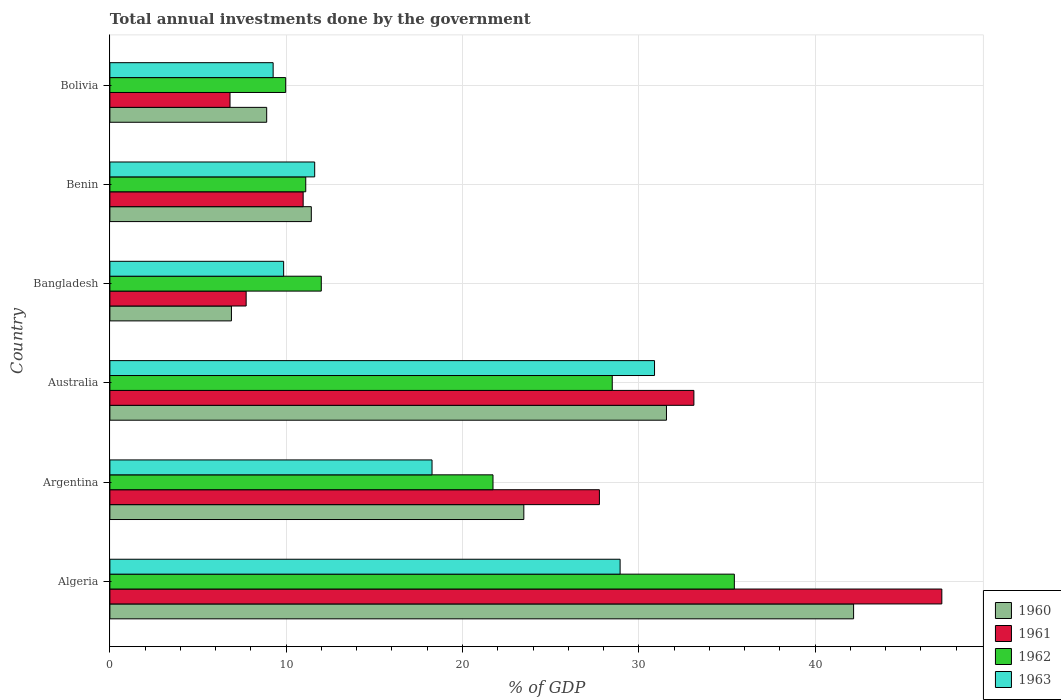How many different coloured bars are there?
Provide a succinct answer. 4. How many bars are there on the 3rd tick from the top?
Offer a terse response. 4. How many bars are there on the 1st tick from the bottom?
Provide a short and direct response. 4. What is the label of the 2nd group of bars from the top?
Keep it short and to the point. Benin. In how many cases, is the number of bars for a given country not equal to the number of legend labels?
Keep it short and to the point. 0. What is the total annual investments done by the government in 1962 in Bangladesh?
Make the answer very short. 11.99. Across all countries, what is the maximum total annual investments done by the government in 1960?
Offer a very short reply. 42.18. Across all countries, what is the minimum total annual investments done by the government in 1960?
Offer a terse response. 6.89. In which country was the total annual investments done by the government in 1962 maximum?
Make the answer very short. Algeria. In which country was the total annual investments done by the government in 1960 minimum?
Your response must be concise. Bangladesh. What is the total total annual investments done by the government in 1962 in the graph?
Ensure brevity in your answer.  118.72. What is the difference between the total annual investments done by the government in 1962 in Argentina and that in Bangladesh?
Make the answer very short. 9.74. What is the difference between the total annual investments done by the government in 1963 in Australia and the total annual investments done by the government in 1960 in Benin?
Offer a very short reply. 19.47. What is the average total annual investments done by the government in 1962 per country?
Your answer should be very brief. 19.79. What is the difference between the total annual investments done by the government in 1961 and total annual investments done by the government in 1963 in Australia?
Provide a short and direct response. 2.23. What is the ratio of the total annual investments done by the government in 1961 in Australia to that in Benin?
Make the answer very short. 3.02. Is the total annual investments done by the government in 1961 in Algeria less than that in Bolivia?
Provide a short and direct response. No. What is the difference between the highest and the second highest total annual investments done by the government in 1962?
Give a very brief answer. 6.93. What is the difference between the highest and the lowest total annual investments done by the government in 1962?
Give a very brief answer. 25.45. Is it the case that in every country, the sum of the total annual investments done by the government in 1963 and total annual investments done by the government in 1962 is greater than the sum of total annual investments done by the government in 1961 and total annual investments done by the government in 1960?
Your answer should be compact. No. What does the 4th bar from the bottom in Bangladesh represents?
Your answer should be compact. 1963. Is it the case that in every country, the sum of the total annual investments done by the government in 1960 and total annual investments done by the government in 1963 is greater than the total annual investments done by the government in 1962?
Keep it short and to the point. Yes. How many bars are there?
Keep it short and to the point. 24. What is the difference between two consecutive major ticks on the X-axis?
Provide a succinct answer. 10. Does the graph contain any zero values?
Your answer should be compact. No. Does the graph contain grids?
Keep it short and to the point. Yes. How are the legend labels stacked?
Provide a short and direct response. Vertical. What is the title of the graph?
Your answer should be compact. Total annual investments done by the government. Does "1982" appear as one of the legend labels in the graph?
Your response must be concise. No. What is the label or title of the X-axis?
Give a very brief answer. % of GDP. What is the label or title of the Y-axis?
Your response must be concise. Country. What is the % of GDP of 1960 in Algeria?
Give a very brief answer. 42.18. What is the % of GDP of 1961 in Algeria?
Your answer should be very brief. 47.19. What is the % of GDP of 1962 in Algeria?
Give a very brief answer. 35.42. What is the % of GDP in 1963 in Algeria?
Keep it short and to the point. 28.94. What is the % of GDP in 1960 in Argentina?
Offer a very short reply. 23.48. What is the % of GDP of 1961 in Argentina?
Keep it short and to the point. 27.77. What is the % of GDP of 1962 in Argentina?
Offer a terse response. 21.73. What is the % of GDP of 1963 in Argentina?
Ensure brevity in your answer.  18.27. What is the % of GDP of 1960 in Australia?
Give a very brief answer. 31.57. What is the % of GDP in 1961 in Australia?
Your answer should be very brief. 33.13. What is the % of GDP in 1962 in Australia?
Provide a short and direct response. 28.49. What is the % of GDP of 1963 in Australia?
Ensure brevity in your answer.  30.89. What is the % of GDP of 1960 in Bangladesh?
Your response must be concise. 6.89. What is the % of GDP of 1961 in Bangladesh?
Your response must be concise. 7.73. What is the % of GDP of 1962 in Bangladesh?
Keep it short and to the point. 11.99. What is the % of GDP in 1963 in Bangladesh?
Your answer should be compact. 9.86. What is the % of GDP of 1960 in Benin?
Your answer should be compact. 11.42. What is the % of GDP in 1961 in Benin?
Make the answer very short. 10.96. What is the % of GDP in 1962 in Benin?
Provide a short and direct response. 11.11. What is the % of GDP of 1963 in Benin?
Make the answer very short. 11.62. What is the % of GDP in 1960 in Bolivia?
Keep it short and to the point. 8.89. What is the % of GDP in 1961 in Bolivia?
Offer a very short reply. 6.81. What is the % of GDP in 1962 in Bolivia?
Your answer should be compact. 9.97. What is the % of GDP of 1963 in Bolivia?
Your answer should be compact. 9.26. Across all countries, what is the maximum % of GDP in 1960?
Keep it short and to the point. 42.18. Across all countries, what is the maximum % of GDP of 1961?
Give a very brief answer. 47.19. Across all countries, what is the maximum % of GDP of 1962?
Ensure brevity in your answer.  35.42. Across all countries, what is the maximum % of GDP of 1963?
Your response must be concise. 30.89. Across all countries, what is the minimum % of GDP in 1960?
Make the answer very short. 6.89. Across all countries, what is the minimum % of GDP of 1961?
Your answer should be very brief. 6.81. Across all countries, what is the minimum % of GDP in 1962?
Make the answer very short. 9.97. Across all countries, what is the minimum % of GDP of 1963?
Offer a terse response. 9.26. What is the total % of GDP in 1960 in the graph?
Your answer should be very brief. 124.45. What is the total % of GDP of 1961 in the graph?
Offer a terse response. 133.59. What is the total % of GDP of 1962 in the graph?
Keep it short and to the point. 118.72. What is the total % of GDP of 1963 in the graph?
Keep it short and to the point. 108.84. What is the difference between the % of GDP in 1960 in Algeria and that in Argentina?
Make the answer very short. 18.71. What is the difference between the % of GDP of 1961 in Algeria and that in Argentina?
Make the answer very short. 19.42. What is the difference between the % of GDP in 1962 in Algeria and that in Argentina?
Provide a short and direct response. 13.69. What is the difference between the % of GDP in 1963 in Algeria and that in Argentina?
Your answer should be very brief. 10.67. What is the difference between the % of GDP of 1960 in Algeria and that in Australia?
Offer a terse response. 10.61. What is the difference between the % of GDP in 1961 in Algeria and that in Australia?
Your response must be concise. 14.06. What is the difference between the % of GDP in 1962 in Algeria and that in Australia?
Your response must be concise. 6.93. What is the difference between the % of GDP of 1963 in Algeria and that in Australia?
Your answer should be very brief. -1.95. What is the difference between the % of GDP in 1960 in Algeria and that in Bangladesh?
Your answer should be compact. 35.29. What is the difference between the % of GDP in 1961 in Algeria and that in Bangladesh?
Your response must be concise. 39.46. What is the difference between the % of GDP in 1962 in Algeria and that in Bangladesh?
Your response must be concise. 23.43. What is the difference between the % of GDP of 1963 in Algeria and that in Bangladesh?
Your response must be concise. 19.09. What is the difference between the % of GDP in 1960 in Algeria and that in Benin?
Provide a succinct answer. 30.76. What is the difference between the % of GDP in 1961 in Algeria and that in Benin?
Provide a short and direct response. 36.23. What is the difference between the % of GDP of 1962 in Algeria and that in Benin?
Ensure brevity in your answer.  24.31. What is the difference between the % of GDP in 1963 in Algeria and that in Benin?
Your answer should be compact. 17.32. What is the difference between the % of GDP of 1960 in Algeria and that in Bolivia?
Your response must be concise. 33.29. What is the difference between the % of GDP of 1961 in Algeria and that in Bolivia?
Make the answer very short. 40.38. What is the difference between the % of GDP of 1962 in Algeria and that in Bolivia?
Your answer should be very brief. 25.45. What is the difference between the % of GDP in 1963 in Algeria and that in Bolivia?
Ensure brevity in your answer.  19.68. What is the difference between the % of GDP of 1960 in Argentina and that in Australia?
Your response must be concise. -8.09. What is the difference between the % of GDP in 1961 in Argentina and that in Australia?
Keep it short and to the point. -5.36. What is the difference between the % of GDP in 1962 in Argentina and that in Australia?
Your response must be concise. -6.76. What is the difference between the % of GDP of 1963 in Argentina and that in Australia?
Provide a succinct answer. -12.62. What is the difference between the % of GDP of 1960 in Argentina and that in Bangladesh?
Ensure brevity in your answer.  16.59. What is the difference between the % of GDP of 1961 in Argentina and that in Bangladesh?
Provide a short and direct response. 20.04. What is the difference between the % of GDP in 1962 in Argentina and that in Bangladesh?
Offer a terse response. 9.74. What is the difference between the % of GDP of 1963 in Argentina and that in Bangladesh?
Offer a terse response. 8.42. What is the difference between the % of GDP in 1960 in Argentina and that in Benin?
Your answer should be very brief. 12.05. What is the difference between the % of GDP in 1961 in Argentina and that in Benin?
Make the answer very short. 16.8. What is the difference between the % of GDP of 1962 in Argentina and that in Benin?
Give a very brief answer. 10.62. What is the difference between the % of GDP of 1963 in Argentina and that in Benin?
Your answer should be compact. 6.66. What is the difference between the % of GDP of 1960 in Argentina and that in Bolivia?
Provide a succinct answer. 14.59. What is the difference between the % of GDP of 1961 in Argentina and that in Bolivia?
Offer a terse response. 20.95. What is the difference between the % of GDP of 1962 in Argentina and that in Bolivia?
Ensure brevity in your answer.  11.76. What is the difference between the % of GDP of 1963 in Argentina and that in Bolivia?
Offer a very short reply. 9.01. What is the difference between the % of GDP in 1960 in Australia and that in Bangladesh?
Offer a very short reply. 24.68. What is the difference between the % of GDP of 1961 in Australia and that in Bangladesh?
Offer a very short reply. 25.4. What is the difference between the % of GDP in 1962 in Australia and that in Bangladesh?
Your answer should be very brief. 16.5. What is the difference between the % of GDP of 1963 in Australia and that in Bangladesh?
Your answer should be compact. 21.04. What is the difference between the % of GDP in 1960 in Australia and that in Benin?
Give a very brief answer. 20.15. What is the difference between the % of GDP of 1961 in Australia and that in Benin?
Ensure brevity in your answer.  22.16. What is the difference between the % of GDP of 1962 in Australia and that in Benin?
Ensure brevity in your answer.  17.39. What is the difference between the % of GDP of 1963 in Australia and that in Benin?
Provide a succinct answer. 19.28. What is the difference between the % of GDP of 1960 in Australia and that in Bolivia?
Give a very brief answer. 22.68. What is the difference between the % of GDP in 1961 in Australia and that in Bolivia?
Offer a very short reply. 26.31. What is the difference between the % of GDP of 1962 in Australia and that in Bolivia?
Your response must be concise. 18.52. What is the difference between the % of GDP of 1963 in Australia and that in Bolivia?
Your answer should be very brief. 21.63. What is the difference between the % of GDP in 1960 in Bangladesh and that in Benin?
Provide a succinct answer. -4.53. What is the difference between the % of GDP in 1961 in Bangladesh and that in Benin?
Offer a terse response. -3.23. What is the difference between the % of GDP in 1962 in Bangladesh and that in Benin?
Give a very brief answer. 0.88. What is the difference between the % of GDP in 1963 in Bangladesh and that in Benin?
Offer a very short reply. -1.76. What is the difference between the % of GDP in 1961 in Bangladesh and that in Bolivia?
Keep it short and to the point. 0.92. What is the difference between the % of GDP in 1962 in Bangladesh and that in Bolivia?
Offer a terse response. 2.02. What is the difference between the % of GDP in 1963 in Bangladesh and that in Bolivia?
Give a very brief answer. 0.6. What is the difference between the % of GDP of 1960 in Benin and that in Bolivia?
Provide a succinct answer. 2.53. What is the difference between the % of GDP in 1961 in Benin and that in Bolivia?
Provide a succinct answer. 4.15. What is the difference between the % of GDP of 1962 in Benin and that in Bolivia?
Offer a terse response. 1.14. What is the difference between the % of GDP of 1963 in Benin and that in Bolivia?
Make the answer very short. 2.36. What is the difference between the % of GDP in 1960 in Algeria and the % of GDP in 1961 in Argentina?
Your answer should be compact. 14.42. What is the difference between the % of GDP in 1960 in Algeria and the % of GDP in 1962 in Argentina?
Give a very brief answer. 20.45. What is the difference between the % of GDP in 1960 in Algeria and the % of GDP in 1963 in Argentina?
Keep it short and to the point. 23.91. What is the difference between the % of GDP of 1961 in Algeria and the % of GDP of 1962 in Argentina?
Make the answer very short. 25.46. What is the difference between the % of GDP in 1961 in Algeria and the % of GDP in 1963 in Argentina?
Offer a terse response. 28.92. What is the difference between the % of GDP of 1962 in Algeria and the % of GDP of 1963 in Argentina?
Offer a very short reply. 17.15. What is the difference between the % of GDP of 1960 in Algeria and the % of GDP of 1961 in Australia?
Your response must be concise. 9.06. What is the difference between the % of GDP in 1960 in Algeria and the % of GDP in 1962 in Australia?
Your answer should be very brief. 13.69. What is the difference between the % of GDP of 1960 in Algeria and the % of GDP of 1963 in Australia?
Give a very brief answer. 11.29. What is the difference between the % of GDP in 1961 in Algeria and the % of GDP in 1962 in Australia?
Your response must be concise. 18.69. What is the difference between the % of GDP in 1961 in Algeria and the % of GDP in 1963 in Australia?
Keep it short and to the point. 16.3. What is the difference between the % of GDP in 1962 in Algeria and the % of GDP in 1963 in Australia?
Give a very brief answer. 4.53. What is the difference between the % of GDP in 1960 in Algeria and the % of GDP in 1961 in Bangladesh?
Keep it short and to the point. 34.46. What is the difference between the % of GDP in 1960 in Algeria and the % of GDP in 1962 in Bangladesh?
Provide a short and direct response. 30.19. What is the difference between the % of GDP in 1960 in Algeria and the % of GDP in 1963 in Bangladesh?
Your answer should be very brief. 32.33. What is the difference between the % of GDP of 1961 in Algeria and the % of GDP of 1962 in Bangladesh?
Your answer should be compact. 35.2. What is the difference between the % of GDP in 1961 in Algeria and the % of GDP in 1963 in Bangladesh?
Ensure brevity in your answer.  37.33. What is the difference between the % of GDP in 1962 in Algeria and the % of GDP in 1963 in Bangladesh?
Make the answer very short. 25.57. What is the difference between the % of GDP in 1960 in Algeria and the % of GDP in 1961 in Benin?
Offer a terse response. 31.22. What is the difference between the % of GDP in 1960 in Algeria and the % of GDP in 1962 in Benin?
Offer a very short reply. 31.08. What is the difference between the % of GDP in 1960 in Algeria and the % of GDP in 1963 in Benin?
Provide a short and direct response. 30.57. What is the difference between the % of GDP in 1961 in Algeria and the % of GDP in 1962 in Benin?
Provide a succinct answer. 36.08. What is the difference between the % of GDP of 1961 in Algeria and the % of GDP of 1963 in Benin?
Provide a succinct answer. 35.57. What is the difference between the % of GDP in 1962 in Algeria and the % of GDP in 1963 in Benin?
Make the answer very short. 23.8. What is the difference between the % of GDP of 1960 in Algeria and the % of GDP of 1961 in Bolivia?
Your response must be concise. 35.37. What is the difference between the % of GDP of 1960 in Algeria and the % of GDP of 1962 in Bolivia?
Keep it short and to the point. 32.21. What is the difference between the % of GDP of 1960 in Algeria and the % of GDP of 1963 in Bolivia?
Your answer should be very brief. 32.92. What is the difference between the % of GDP of 1961 in Algeria and the % of GDP of 1962 in Bolivia?
Provide a succinct answer. 37.22. What is the difference between the % of GDP in 1961 in Algeria and the % of GDP in 1963 in Bolivia?
Make the answer very short. 37.93. What is the difference between the % of GDP in 1962 in Algeria and the % of GDP in 1963 in Bolivia?
Your answer should be compact. 26.16. What is the difference between the % of GDP of 1960 in Argentina and the % of GDP of 1961 in Australia?
Offer a terse response. -9.65. What is the difference between the % of GDP of 1960 in Argentina and the % of GDP of 1962 in Australia?
Your answer should be very brief. -5.02. What is the difference between the % of GDP of 1960 in Argentina and the % of GDP of 1963 in Australia?
Offer a very short reply. -7.41. What is the difference between the % of GDP in 1961 in Argentina and the % of GDP in 1962 in Australia?
Give a very brief answer. -0.73. What is the difference between the % of GDP of 1961 in Argentina and the % of GDP of 1963 in Australia?
Offer a terse response. -3.13. What is the difference between the % of GDP in 1962 in Argentina and the % of GDP in 1963 in Australia?
Make the answer very short. -9.16. What is the difference between the % of GDP of 1960 in Argentina and the % of GDP of 1961 in Bangladesh?
Give a very brief answer. 15.75. What is the difference between the % of GDP of 1960 in Argentina and the % of GDP of 1962 in Bangladesh?
Provide a succinct answer. 11.49. What is the difference between the % of GDP in 1960 in Argentina and the % of GDP in 1963 in Bangladesh?
Your answer should be compact. 13.62. What is the difference between the % of GDP in 1961 in Argentina and the % of GDP in 1962 in Bangladesh?
Provide a succinct answer. 15.78. What is the difference between the % of GDP in 1961 in Argentina and the % of GDP in 1963 in Bangladesh?
Your answer should be very brief. 17.91. What is the difference between the % of GDP in 1962 in Argentina and the % of GDP in 1963 in Bangladesh?
Give a very brief answer. 11.88. What is the difference between the % of GDP in 1960 in Argentina and the % of GDP in 1961 in Benin?
Make the answer very short. 12.52. What is the difference between the % of GDP of 1960 in Argentina and the % of GDP of 1962 in Benin?
Make the answer very short. 12.37. What is the difference between the % of GDP of 1960 in Argentina and the % of GDP of 1963 in Benin?
Make the answer very short. 11.86. What is the difference between the % of GDP of 1961 in Argentina and the % of GDP of 1962 in Benin?
Make the answer very short. 16.66. What is the difference between the % of GDP in 1961 in Argentina and the % of GDP in 1963 in Benin?
Offer a very short reply. 16.15. What is the difference between the % of GDP of 1962 in Argentina and the % of GDP of 1963 in Benin?
Your answer should be very brief. 10.11. What is the difference between the % of GDP in 1960 in Argentina and the % of GDP in 1961 in Bolivia?
Give a very brief answer. 16.67. What is the difference between the % of GDP of 1960 in Argentina and the % of GDP of 1962 in Bolivia?
Your response must be concise. 13.51. What is the difference between the % of GDP of 1960 in Argentina and the % of GDP of 1963 in Bolivia?
Offer a terse response. 14.22. What is the difference between the % of GDP in 1961 in Argentina and the % of GDP in 1962 in Bolivia?
Your response must be concise. 17.8. What is the difference between the % of GDP of 1961 in Argentina and the % of GDP of 1963 in Bolivia?
Ensure brevity in your answer.  18.51. What is the difference between the % of GDP in 1962 in Argentina and the % of GDP in 1963 in Bolivia?
Your response must be concise. 12.47. What is the difference between the % of GDP of 1960 in Australia and the % of GDP of 1961 in Bangladesh?
Your answer should be very brief. 23.84. What is the difference between the % of GDP in 1960 in Australia and the % of GDP in 1962 in Bangladesh?
Offer a terse response. 19.58. What is the difference between the % of GDP of 1960 in Australia and the % of GDP of 1963 in Bangladesh?
Make the answer very short. 21.71. What is the difference between the % of GDP of 1961 in Australia and the % of GDP of 1962 in Bangladesh?
Make the answer very short. 21.14. What is the difference between the % of GDP in 1961 in Australia and the % of GDP in 1963 in Bangladesh?
Give a very brief answer. 23.27. What is the difference between the % of GDP in 1962 in Australia and the % of GDP in 1963 in Bangladesh?
Provide a succinct answer. 18.64. What is the difference between the % of GDP of 1960 in Australia and the % of GDP of 1961 in Benin?
Make the answer very short. 20.61. What is the difference between the % of GDP of 1960 in Australia and the % of GDP of 1962 in Benin?
Provide a short and direct response. 20.46. What is the difference between the % of GDP of 1960 in Australia and the % of GDP of 1963 in Benin?
Offer a very short reply. 19.95. What is the difference between the % of GDP in 1961 in Australia and the % of GDP in 1962 in Benin?
Your answer should be very brief. 22.02. What is the difference between the % of GDP in 1961 in Australia and the % of GDP in 1963 in Benin?
Give a very brief answer. 21.51. What is the difference between the % of GDP of 1962 in Australia and the % of GDP of 1963 in Benin?
Ensure brevity in your answer.  16.88. What is the difference between the % of GDP of 1960 in Australia and the % of GDP of 1961 in Bolivia?
Keep it short and to the point. 24.76. What is the difference between the % of GDP of 1960 in Australia and the % of GDP of 1962 in Bolivia?
Offer a very short reply. 21.6. What is the difference between the % of GDP in 1960 in Australia and the % of GDP in 1963 in Bolivia?
Give a very brief answer. 22.31. What is the difference between the % of GDP of 1961 in Australia and the % of GDP of 1962 in Bolivia?
Your answer should be very brief. 23.16. What is the difference between the % of GDP in 1961 in Australia and the % of GDP in 1963 in Bolivia?
Offer a terse response. 23.87. What is the difference between the % of GDP in 1962 in Australia and the % of GDP in 1963 in Bolivia?
Provide a succinct answer. 19.23. What is the difference between the % of GDP in 1960 in Bangladesh and the % of GDP in 1961 in Benin?
Offer a very short reply. -4.07. What is the difference between the % of GDP in 1960 in Bangladesh and the % of GDP in 1962 in Benin?
Your response must be concise. -4.21. What is the difference between the % of GDP of 1960 in Bangladesh and the % of GDP of 1963 in Benin?
Provide a succinct answer. -4.72. What is the difference between the % of GDP in 1961 in Bangladesh and the % of GDP in 1962 in Benin?
Offer a terse response. -3.38. What is the difference between the % of GDP of 1961 in Bangladesh and the % of GDP of 1963 in Benin?
Your answer should be compact. -3.89. What is the difference between the % of GDP in 1962 in Bangladesh and the % of GDP in 1963 in Benin?
Your answer should be compact. 0.37. What is the difference between the % of GDP of 1960 in Bangladesh and the % of GDP of 1961 in Bolivia?
Keep it short and to the point. 0.08. What is the difference between the % of GDP in 1960 in Bangladesh and the % of GDP in 1962 in Bolivia?
Your answer should be very brief. -3.08. What is the difference between the % of GDP in 1960 in Bangladesh and the % of GDP in 1963 in Bolivia?
Make the answer very short. -2.37. What is the difference between the % of GDP in 1961 in Bangladesh and the % of GDP in 1962 in Bolivia?
Ensure brevity in your answer.  -2.24. What is the difference between the % of GDP of 1961 in Bangladesh and the % of GDP of 1963 in Bolivia?
Your response must be concise. -1.53. What is the difference between the % of GDP of 1962 in Bangladesh and the % of GDP of 1963 in Bolivia?
Provide a short and direct response. 2.73. What is the difference between the % of GDP of 1960 in Benin and the % of GDP of 1961 in Bolivia?
Offer a terse response. 4.61. What is the difference between the % of GDP in 1960 in Benin and the % of GDP in 1962 in Bolivia?
Make the answer very short. 1.45. What is the difference between the % of GDP in 1960 in Benin and the % of GDP in 1963 in Bolivia?
Ensure brevity in your answer.  2.16. What is the difference between the % of GDP of 1961 in Benin and the % of GDP of 1962 in Bolivia?
Your response must be concise. 0.99. What is the difference between the % of GDP of 1961 in Benin and the % of GDP of 1963 in Bolivia?
Give a very brief answer. 1.7. What is the difference between the % of GDP in 1962 in Benin and the % of GDP in 1963 in Bolivia?
Offer a very short reply. 1.85. What is the average % of GDP of 1960 per country?
Your answer should be very brief. 20.74. What is the average % of GDP of 1961 per country?
Your response must be concise. 22.26. What is the average % of GDP in 1962 per country?
Provide a short and direct response. 19.79. What is the average % of GDP of 1963 per country?
Offer a very short reply. 18.14. What is the difference between the % of GDP in 1960 and % of GDP in 1961 in Algeria?
Provide a short and direct response. -5. What is the difference between the % of GDP in 1960 and % of GDP in 1962 in Algeria?
Ensure brevity in your answer.  6.76. What is the difference between the % of GDP of 1960 and % of GDP of 1963 in Algeria?
Your response must be concise. 13.24. What is the difference between the % of GDP in 1961 and % of GDP in 1962 in Algeria?
Your answer should be very brief. 11.77. What is the difference between the % of GDP in 1961 and % of GDP in 1963 in Algeria?
Your answer should be very brief. 18.25. What is the difference between the % of GDP of 1962 and % of GDP of 1963 in Algeria?
Provide a succinct answer. 6.48. What is the difference between the % of GDP in 1960 and % of GDP in 1961 in Argentina?
Make the answer very short. -4.29. What is the difference between the % of GDP in 1960 and % of GDP in 1962 in Argentina?
Make the answer very short. 1.75. What is the difference between the % of GDP of 1960 and % of GDP of 1963 in Argentina?
Your answer should be very brief. 5.21. What is the difference between the % of GDP of 1961 and % of GDP of 1962 in Argentina?
Offer a terse response. 6.04. What is the difference between the % of GDP of 1961 and % of GDP of 1963 in Argentina?
Your answer should be compact. 9.49. What is the difference between the % of GDP of 1962 and % of GDP of 1963 in Argentina?
Ensure brevity in your answer.  3.46. What is the difference between the % of GDP in 1960 and % of GDP in 1961 in Australia?
Offer a terse response. -1.56. What is the difference between the % of GDP in 1960 and % of GDP in 1962 in Australia?
Ensure brevity in your answer.  3.08. What is the difference between the % of GDP in 1960 and % of GDP in 1963 in Australia?
Offer a terse response. 0.68. What is the difference between the % of GDP in 1961 and % of GDP in 1962 in Australia?
Your response must be concise. 4.63. What is the difference between the % of GDP of 1961 and % of GDP of 1963 in Australia?
Keep it short and to the point. 2.23. What is the difference between the % of GDP of 1962 and % of GDP of 1963 in Australia?
Your response must be concise. -2.4. What is the difference between the % of GDP in 1960 and % of GDP in 1961 in Bangladesh?
Provide a short and direct response. -0.84. What is the difference between the % of GDP in 1960 and % of GDP in 1962 in Bangladesh?
Offer a terse response. -5.1. What is the difference between the % of GDP in 1960 and % of GDP in 1963 in Bangladesh?
Ensure brevity in your answer.  -2.96. What is the difference between the % of GDP in 1961 and % of GDP in 1962 in Bangladesh?
Offer a terse response. -4.26. What is the difference between the % of GDP in 1961 and % of GDP in 1963 in Bangladesh?
Your response must be concise. -2.13. What is the difference between the % of GDP of 1962 and % of GDP of 1963 in Bangladesh?
Give a very brief answer. 2.13. What is the difference between the % of GDP in 1960 and % of GDP in 1961 in Benin?
Your response must be concise. 0.46. What is the difference between the % of GDP in 1960 and % of GDP in 1962 in Benin?
Make the answer very short. 0.32. What is the difference between the % of GDP of 1960 and % of GDP of 1963 in Benin?
Ensure brevity in your answer.  -0.19. What is the difference between the % of GDP of 1961 and % of GDP of 1962 in Benin?
Provide a succinct answer. -0.15. What is the difference between the % of GDP in 1961 and % of GDP in 1963 in Benin?
Keep it short and to the point. -0.65. What is the difference between the % of GDP in 1962 and % of GDP in 1963 in Benin?
Your response must be concise. -0.51. What is the difference between the % of GDP in 1960 and % of GDP in 1961 in Bolivia?
Your answer should be compact. 2.08. What is the difference between the % of GDP of 1960 and % of GDP of 1962 in Bolivia?
Give a very brief answer. -1.08. What is the difference between the % of GDP of 1960 and % of GDP of 1963 in Bolivia?
Your response must be concise. -0.37. What is the difference between the % of GDP of 1961 and % of GDP of 1962 in Bolivia?
Offer a very short reply. -3.16. What is the difference between the % of GDP of 1961 and % of GDP of 1963 in Bolivia?
Ensure brevity in your answer.  -2.45. What is the difference between the % of GDP of 1962 and % of GDP of 1963 in Bolivia?
Make the answer very short. 0.71. What is the ratio of the % of GDP in 1960 in Algeria to that in Argentina?
Your answer should be compact. 1.8. What is the ratio of the % of GDP in 1961 in Algeria to that in Argentina?
Offer a very short reply. 1.7. What is the ratio of the % of GDP of 1962 in Algeria to that in Argentina?
Ensure brevity in your answer.  1.63. What is the ratio of the % of GDP in 1963 in Algeria to that in Argentina?
Provide a short and direct response. 1.58. What is the ratio of the % of GDP of 1960 in Algeria to that in Australia?
Provide a succinct answer. 1.34. What is the ratio of the % of GDP in 1961 in Algeria to that in Australia?
Give a very brief answer. 1.42. What is the ratio of the % of GDP in 1962 in Algeria to that in Australia?
Offer a terse response. 1.24. What is the ratio of the % of GDP of 1963 in Algeria to that in Australia?
Ensure brevity in your answer.  0.94. What is the ratio of the % of GDP of 1960 in Algeria to that in Bangladesh?
Your answer should be compact. 6.12. What is the ratio of the % of GDP of 1961 in Algeria to that in Bangladesh?
Offer a very short reply. 6.11. What is the ratio of the % of GDP of 1962 in Algeria to that in Bangladesh?
Provide a succinct answer. 2.95. What is the ratio of the % of GDP of 1963 in Algeria to that in Bangladesh?
Ensure brevity in your answer.  2.94. What is the ratio of the % of GDP in 1960 in Algeria to that in Benin?
Keep it short and to the point. 3.69. What is the ratio of the % of GDP of 1961 in Algeria to that in Benin?
Keep it short and to the point. 4.3. What is the ratio of the % of GDP in 1962 in Algeria to that in Benin?
Offer a very short reply. 3.19. What is the ratio of the % of GDP of 1963 in Algeria to that in Benin?
Keep it short and to the point. 2.49. What is the ratio of the % of GDP of 1960 in Algeria to that in Bolivia?
Ensure brevity in your answer.  4.74. What is the ratio of the % of GDP of 1961 in Algeria to that in Bolivia?
Ensure brevity in your answer.  6.93. What is the ratio of the % of GDP in 1962 in Algeria to that in Bolivia?
Keep it short and to the point. 3.55. What is the ratio of the % of GDP of 1963 in Algeria to that in Bolivia?
Keep it short and to the point. 3.13. What is the ratio of the % of GDP in 1960 in Argentina to that in Australia?
Provide a succinct answer. 0.74. What is the ratio of the % of GDP in 1961 in Argentina to that in Australia?
Give a very brief answer. 0.84. What is the ratio of the % of GDP of 1962 in Argentina to that in Australia?
Provide a succinct answer. 0.76. What is the ratio of the % of GDP in 1963 in Argentina to that in Australia?
Ensure brevity in your answer.  0.59. What is the ratio of the % of GDP in 1960 in Argentina to that in Bangladesh?
Offer a terse response. 3.41. What is the ratio of the % of GDP in 1961 in Argentina to that in Bangladesh?
Your answer should be compact. 3.59. What is the ratio of the % of GDP of 1962 in Argentina to that in Bangladesh?
Provide a succinct answer. 1.81. What is the ratio of the % of GDP in 1963 in Argentina to that in Bangladesh?
Your response must be concise. 1.85. What is the ratio of the % of GDP of 1960 in Argentina to that in Benin?
Ensure brevity in your answer.  2.06. What is the ratio of the % of GDP of 1961 in Argentina to that in Benin?
Your response must be concise. 2.53. What is the ratio of the % of GDP in 1962 in Argentina to that in Benin?
Your answer should be very brief. 1.96. What is the ratio of the % of GDP of 1963 in Argentina to that in Benin?
Give a very brief answer. 1.57. What is the ratio of the % of GDP in 1960 in Argentina to that in Bolivia?
Provide a succinct answer. 2.64. What is the ratio of the % of GDP of 1961 in Argentina to that in Bolivia?
Give a very brief answer. 4.07. What is the ratio of the % of GDP in 1962 in Argentina to that in Bolivia?
Offer a terse response. 2.18. What is the ratio of the % of GDP in 1963 in Argentina to that in Bolivia?
Provide a short and direct response. 1.97. What is the ratio of the % of GDP in 1960 in Australia to that in Bangladesh?
Your answer should be compact. 4.58. What is the ratio of the % of GDP of 1961 in Australia to that in Bangladesh?
Offer a very short reply. 4.29. What is the ratio of the % of GDP of 1962 in Australia to that in Bangladesh?
Provide a short and direct response. 2.38. What is the ratio of the % of GDP in 1963 in Australia to that in Bangladesh?
Ensure brevity in your answer.  3.13. What is the ratio of the % of GDP of 1960 in Australia to that in Benin?
Your answer should be compact. 2.76. What is the ratio of the % of GDP in 1961 in Australia to that in Benin?
Make the answer very short. 3.02. What is the ratio of the % of GDP in 1962 in Australia to that in Benin?
Your answer should be compact. 2.56. What is the ratio of the % of GDP in 1963 in Australia to that in Benin?
Offer a very short reply. 2.66. What is the ratio of the % of GDP of 1960 in Australia to that in Bolivia?
Keep it short and to the point. 3.55. What is the ratio of the % of GDP of 1961 in Australia to that in Bolivia?
Ensure brevity in your answer.  4.86. What is the ratio of the % of GDP in 1962 in Australia to that in Bolivia?
Provide a succinct answer. 2.86. What is the ratio of the % of GDP of 1963 in Australia to that in Bolivia?
Your answer should be compact. 3.34. What is the ratio of the % of GDP of 1960 in Bangladesh to that in Benin?
Make the answer very short. 0.6. What is the ratio of the % of GDP in 1961 in Bangladesh to that in Benin?
Provide a short and direct response. 0.71. What is the ratio of the % of GDP in 1962 in Bangladesh to that in Benin?
Your response must be concise. 1.08. What is the ratio of the % of GDP of 1963 in Bangladesh to that in Benin?
Your answer should be very brief. 0.85. What is the ratio of the % of GDP of 1960 in Bangladesh to that in Bolivia?
Your answer should be compact. 0.78. What is the ratio of the % of GDP of 1961 in Bangladesh to that in Bolivia?
Ensure brevity in your answer.  1.13. What is the ratio of the % of GDP of 1962 in Bangladesh to that in Bolivia?
Make the answer very short. 1.2. What is the ratio of the % of GDP in 1963 in Bangladesh to that in Bolivia?
Provide a short and direct response. 1.06. What is the ratio of the % of GDP of 1960 in Benin to that in Bolivia?
Offer a very short reply. 1.28. What is the ratio of the % of GDP in 1961 in Benin to that in Bolivia?
Offer a terse response. 1.61. What is the ratio of the % of GDP of 1962 in Benin to that in Bolivia?
Provide a succinct answer. 1.11. What is the ratio of the % of GDP in 1963 in Benin to that in Bolivia?
Your response must be concise. 1.25. What is the difference between the highest and the second highest % of GDP in 1960?
Provide a succinct answer. 10.61. What is the difference between the highest and the second highest % of GDP of 1961?
Provide a short and direct response. 14.06. What is the difference between the highest and the second highest % of GDP of 1962?
Ensure brevity in your answer.  6.93. What is the difference between the highest and the second highest % of GDP of 1963?
Your response must be concise. 1.95. What is the difference between the highest and the lowest % of GDP of 1960?
Your answer should be compact. 35.29. What is the difference between the highest and the lowest % of GDP in 1961?
Ensure brevity in your answer.  40.38. What is the difference between the highest and the lowest % of GDP of 1962?
Make the answer very short. 25.45. What is the difference between the highest and the lowest % of GDP of 1963?
Your response must be concise. 21.63. 